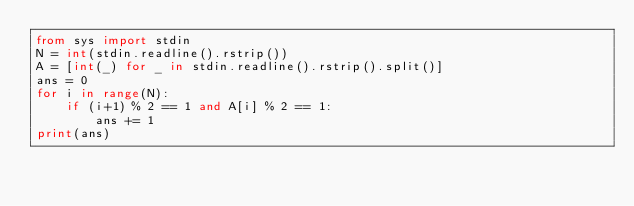Convert code to text. <code><loc_0><loc_0><loc_500><loc_500><_Python_>from sys import stdin
N = int(stdin.readline().rstrip())
A = [int(_) for _ in stdin.readline().rstrip().split()]
ans = 0
for i in range(N):
    if (i+1) % 2 == 1 and A[i] % 2 == 1:
        ans += 1
print(ans)</code> 